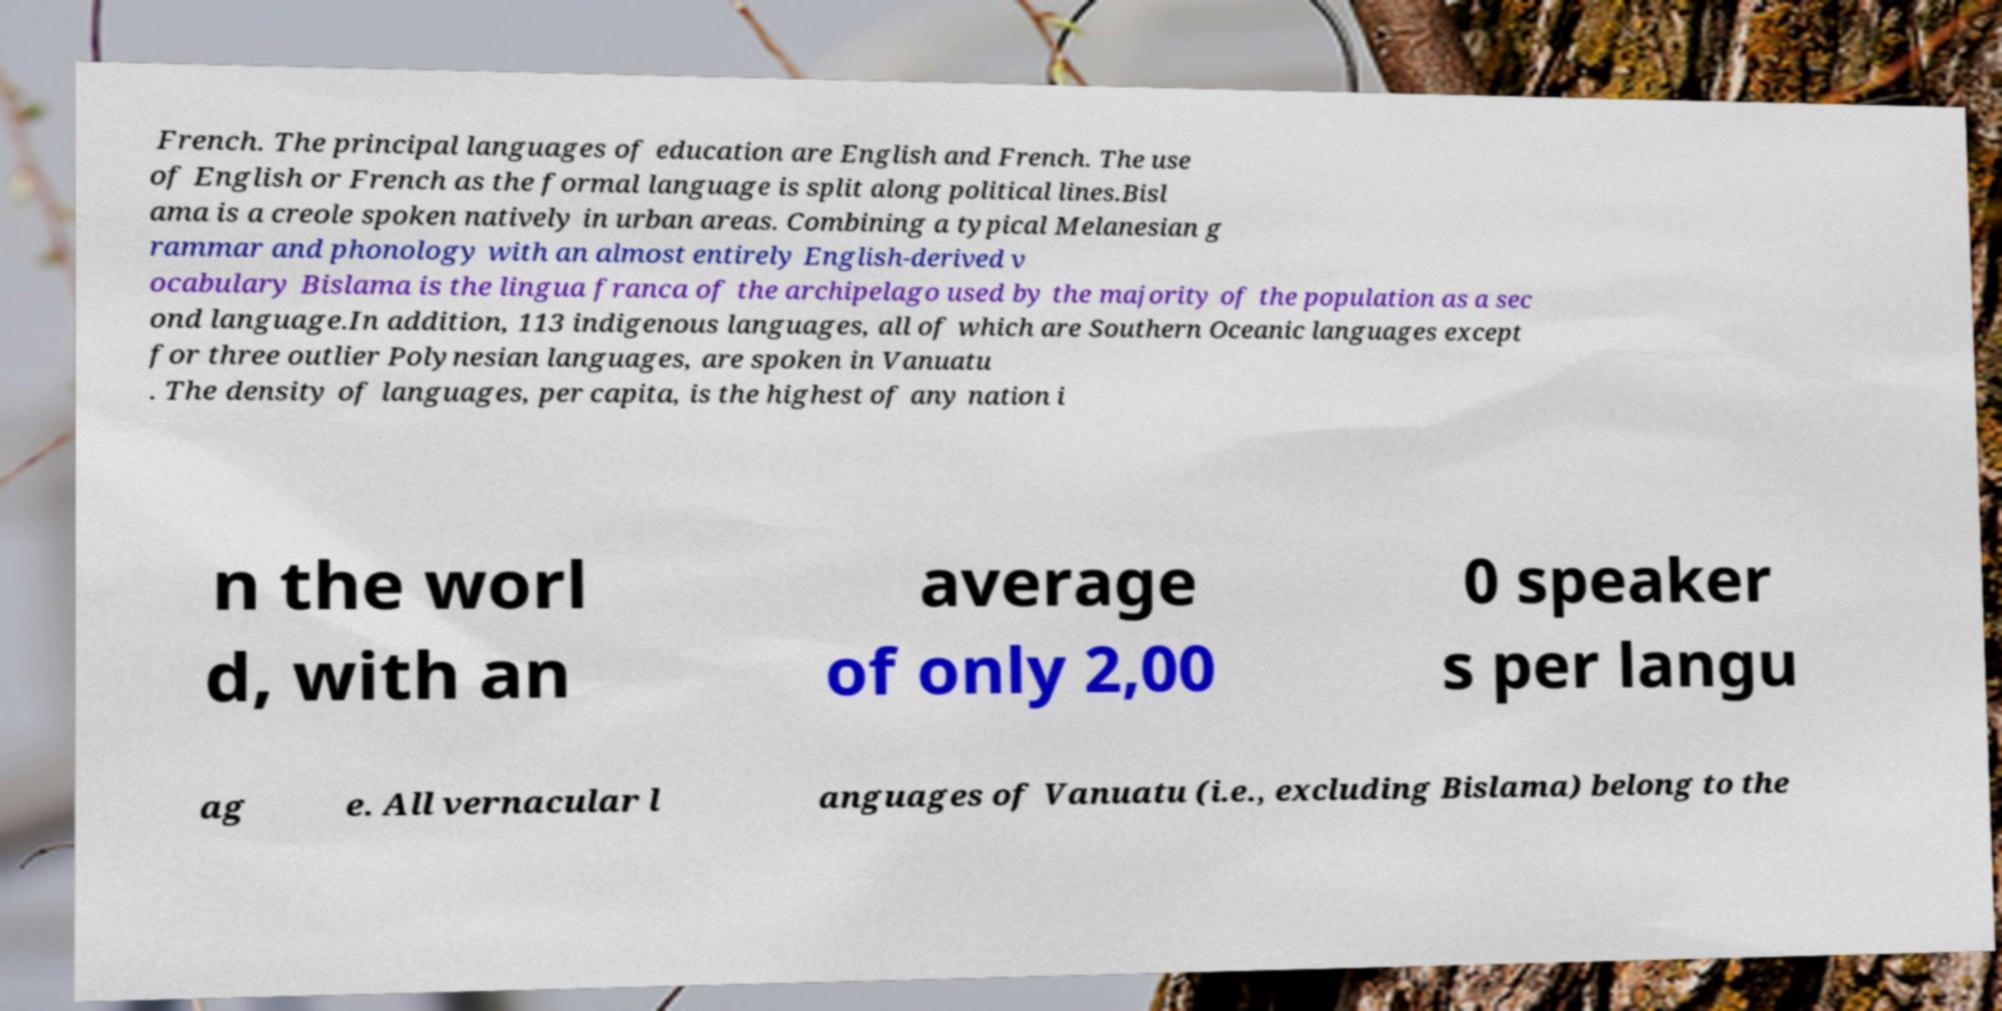Could you extract and type out the text from this image? French. The principal languages of education are English and French. The use of English or French as the formal language is split along political lines.Bisl ama is a creole spoken natively in urban areas. Combining a typical Melanesian g rammar and phonology with an almost entirely English-derived v ocabulary Bislama is the lingua franca of the archipelago used by the majority of the population as a sec ond language.In addition, 113 indigenous languages, all of which are Southern Oceanic languages except for three outlier Polynesian languages, are spoken in Vanuatu . The density of languages, per capita, is the highest of any nation i n the worl d, with an average of only 2,00 0 speaker s per langu ag e. All vernacular l anguages of Vanuatu (i.e., excluding Bislama) belong to the 